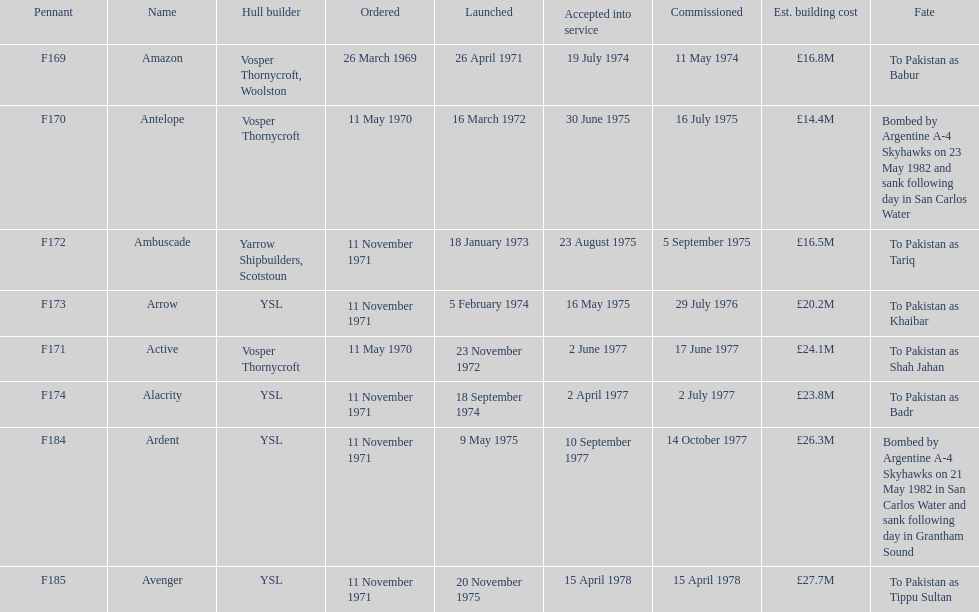How many ships were built after ardent? 1. 